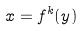Convert formula to latex. <formula><loc_0><loc_0><loc_500><loc_500>x = f ^ { k } ( y )</formula> 